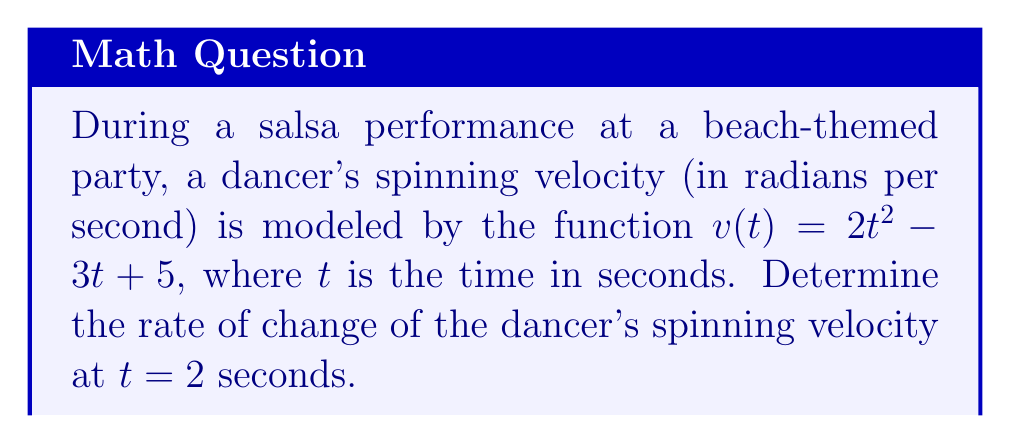Provide a solution to this math problem. To find the rate of change of the dancer's spinning velocity, we need to find the derivative of the velocity function $v(t)$ and evaluate it at $t = 2$ seconds.

Step 1: Find the derivative of $v(t)$.
$v(t) = 2t^2 - 3t + 5$
$v'(t) = \frac{d}{dt}(2t^2 - 3t + 5)$
$v'(t) = 4t - 3$

Step 2: Evaluate $v'(t)$ at $t = 2$ seconds.
$v'(2) = 4(2) - 3$
$v'(2) = 8 - 3$
$v'(2) = 5$

Therefore, the rate of change of the dancer's spinning velocity at $t = 2$ seconds is 5 radians per second squared.
Answer: $5 \text{ rad/s}^2$ 